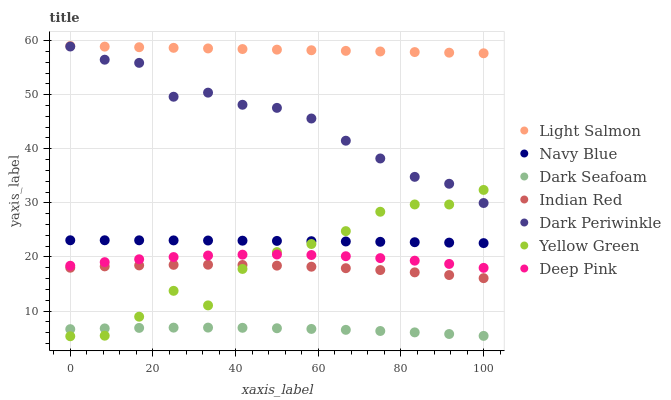Does Dark Seafoam have the minimum area under the curve?
Answer yes or no. Yes. Does Light Salmon have the maximum area under the curve?
Answer yes or no. Yes. Does Deep Pink have the minimum area under the curve?
Answer yes or no. No. Does Deep Pink have the maximum area under the curve?
Answer yes or no. No. Is Light Salmon the smoothest?
Answer yes or no. Yes. Is Yellow Green the roughest?
Answer yes or no. Yes. Is Deep Pink the smoothest?
Answer yes or no. No. Is Deep Pink the roughest?
Answer yes or no. No. Does Yellow Green have the lowest value?
Answer yes or no. Yes. Does Deep Pink have the lowest value?
Answer yes or no. No. Does Light Salmon have the highest value?
Answer yes or no. Yes. Does Deep Pink have the highest value?
Answer yes or no. No. Is Navy Blue less than Dark Periwinkle?
Answer yes or no. Yes. Is Light Salmon greater than Indian Red?
Answer yes or no. Yes. Does Dark Seafoam intersect Yellow Green?
Answer yes or no. Yes. Is Dark Seafoam less than Yellow Green?
Answer yes or no. No. Is Dark Seafoam greater than Yellow Green?
Answer yes or no. No. Does Navy Blue intersect Dark Periwinkle?
Answer yes or no. No. 